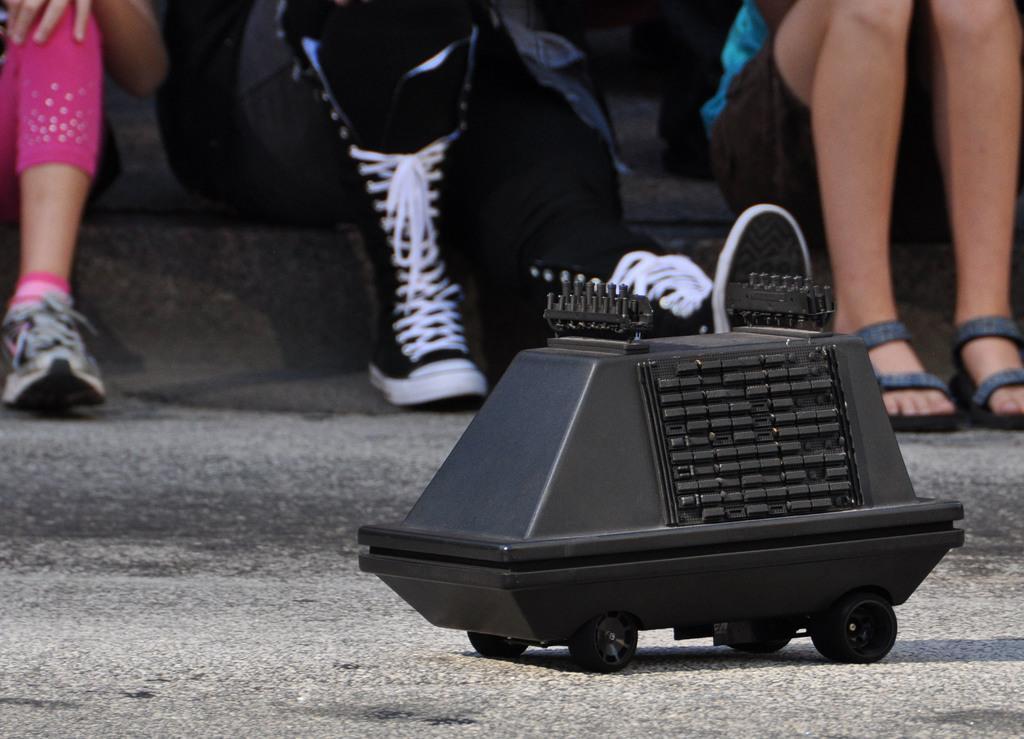Could you give a brief overview of what you see in this image? In the foreground I can see a toy vehicle and three persons are sitting on steps. This image is taken may be during a day. 